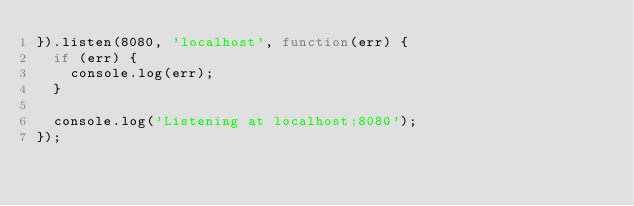Convert code to text. <code><loc_0><loc_0><loc_500><loc_500><_JavaScript_>}).listen(8080, 'localhost', function(err) {
  if (err) {
    console.log(err);
  }

  console.log('Listening at localhost:8080');
});
</code> 